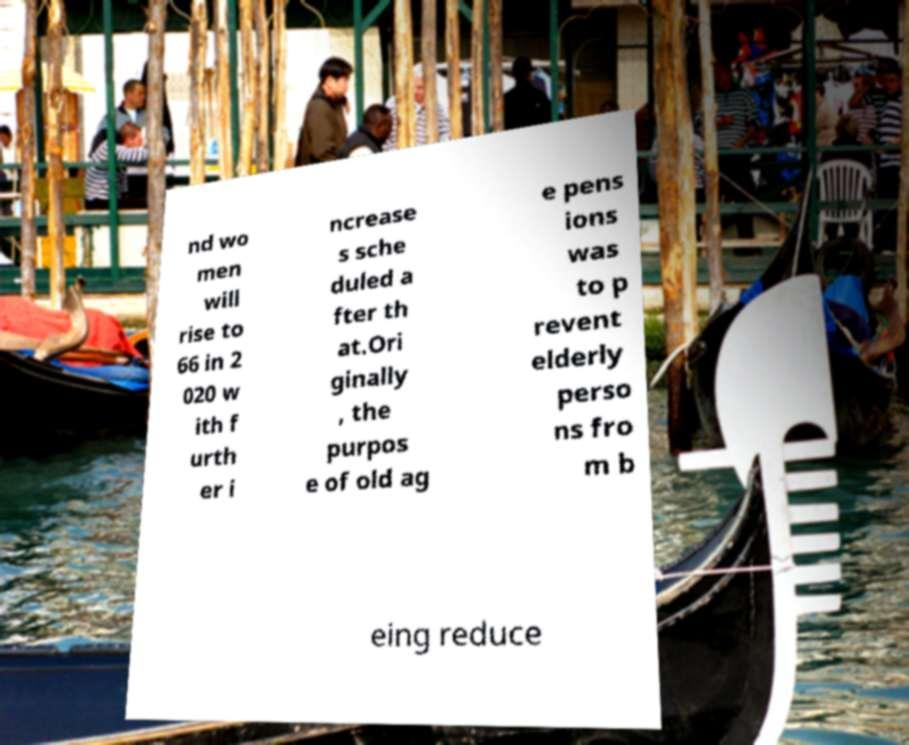What messages or text are displayed in this image? I need them in a readable, typed format. nd wo men will rise to 66 in 2 020 w ith f urth er i ncrease s sche duled a fter th at.Ori ginally , the purpos e of old ag e pens ions was to p revent elderly perso ns fro m b eing reduce 